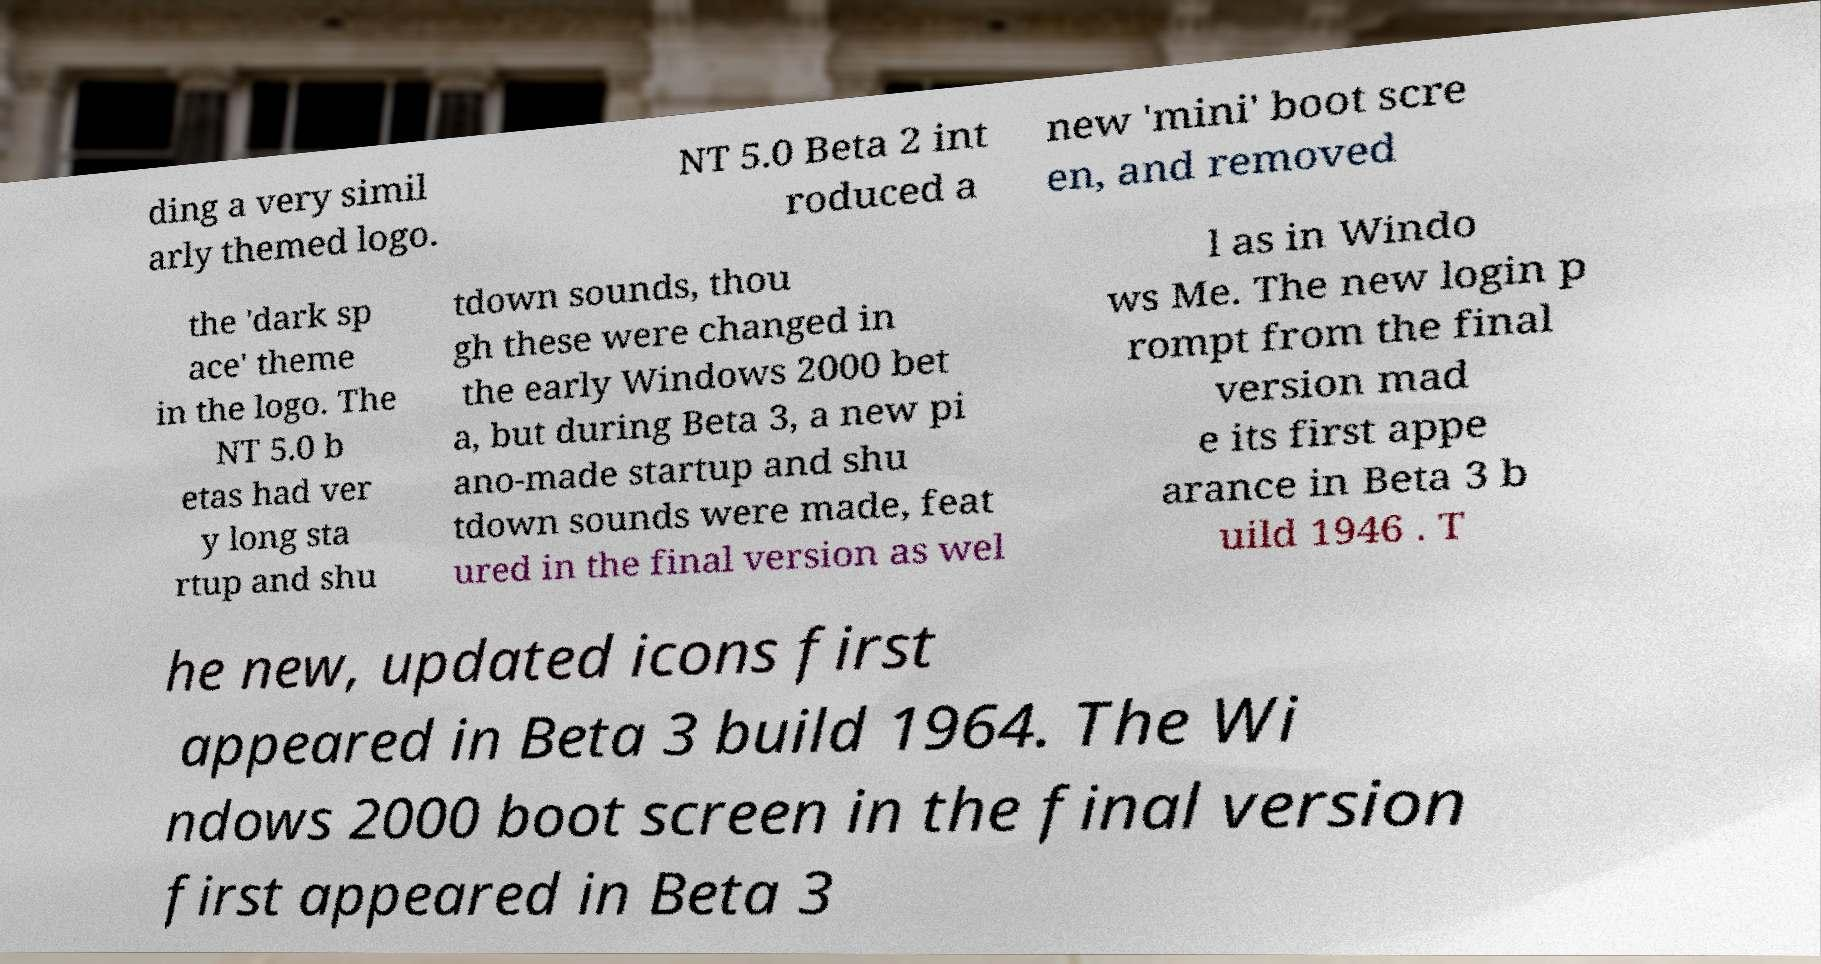Can you accurately transcribe the text from the provided image for me? ding a very simil arly themed logo. NT 5.0 Beta 2 int roduced a new 'mini' boot scre en, and removed the 'dark sp ace' theme in the logo. The NT 5.0 b etas had ver y long sta rtup and shu tdown sounds, thou gh these were changed in the early Windows 2000 bet a, but during Beta 3, a new pi ano-made startup and shu tdown sounds were made, feat ured in the final version as wel l as in Windo ws Me. The new login p rompt from the final version mad e its first appe arance in Beta 3 b uild 1946 . T he new, updated icons first appeared in Beta 3 build 1964. The Wi ndows 2000 boot screen in the final version first appeared in Beta 3 